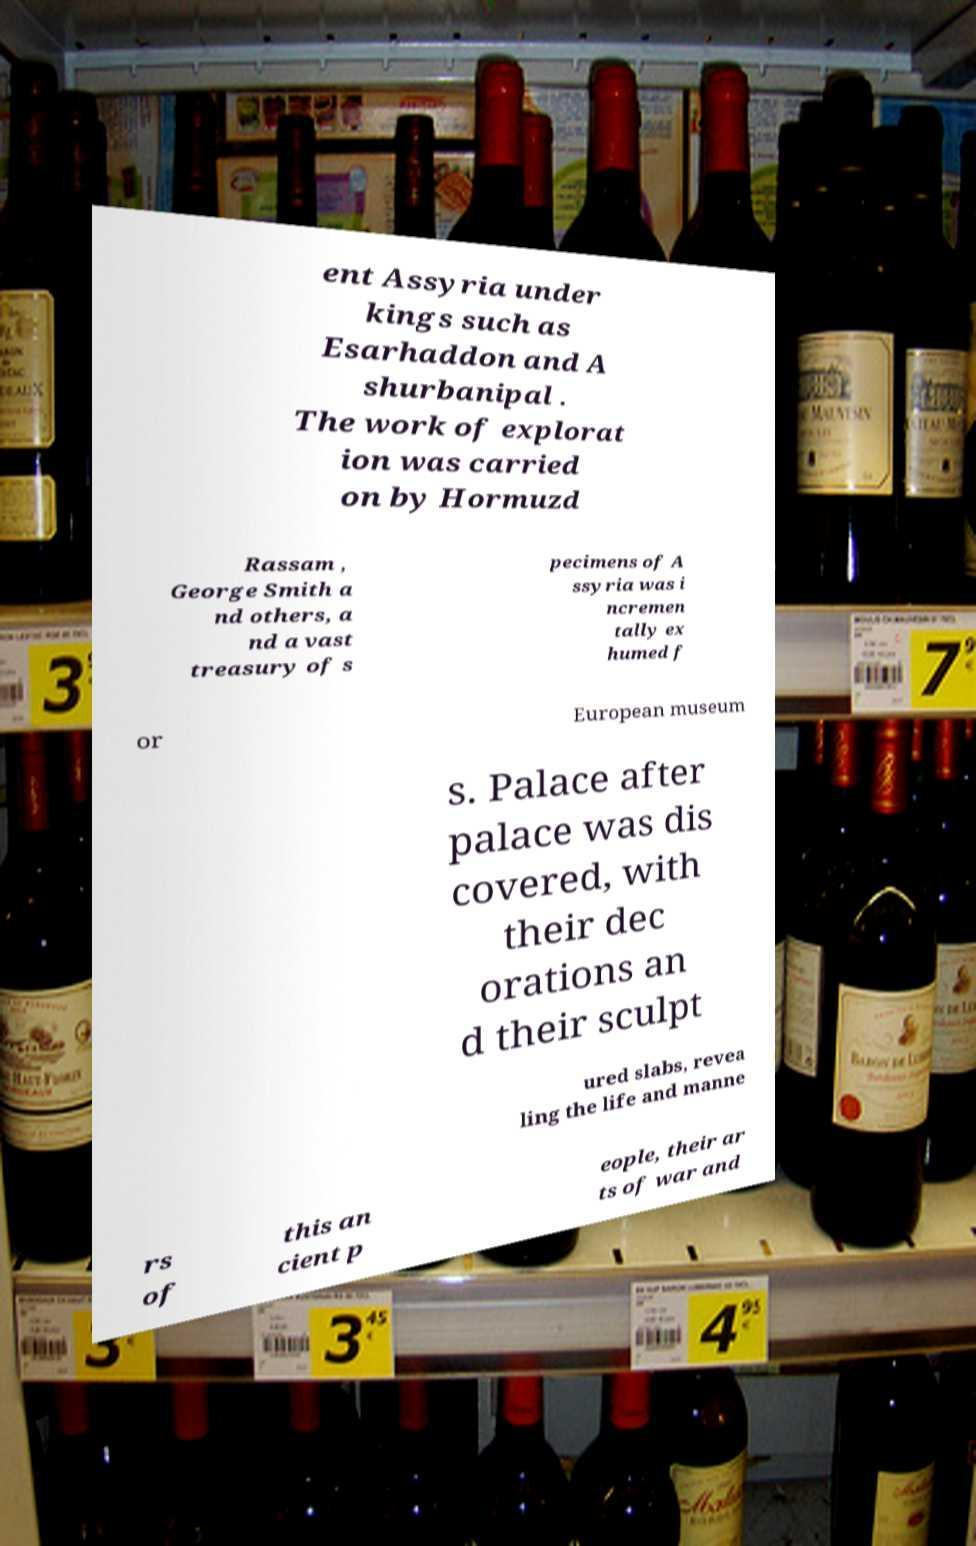Could you assist in decoding the text presented in this image and type it out clearly? ent Assyria under kings such as Esarhaddon and A shurbanipal . The work of explorat ion was carried on by Hormuzd Rassam , George Smith a nd others, a nd a vast treasury of s pecimens of A ssyria was i ncremen tally ex humed f or European museum s. Palace after palace was dis covered, with their dec orations an d their sculpt ured slabs, revea ling the life and manne rs of this an cient p eople, their ar ts of war and 